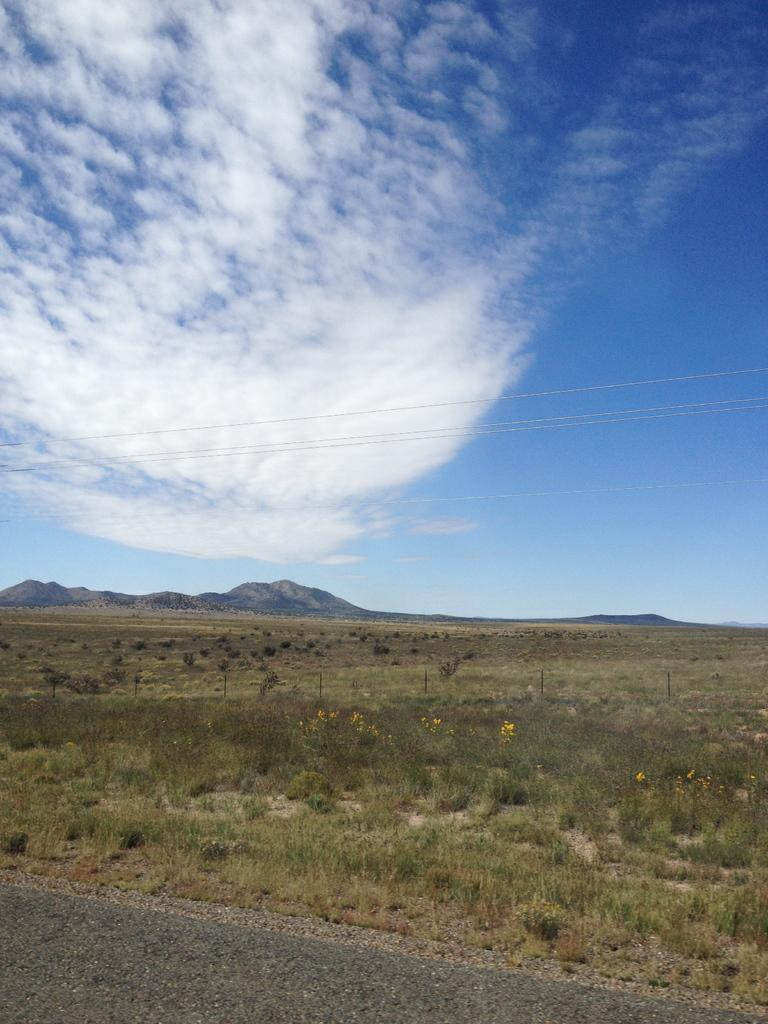What type of landscape is depicted in the image? There is a grassland in the image. What can be seen in the distance behind the grassland? There is a mountain in the background of the image. What part of the natural environment is visible in the image? The sky is visible in the image. What type of stocking can be seen hanging from the tree in the image? There is no stocking present in the image; it features a grassland, a mountain in the background, and the sky. 